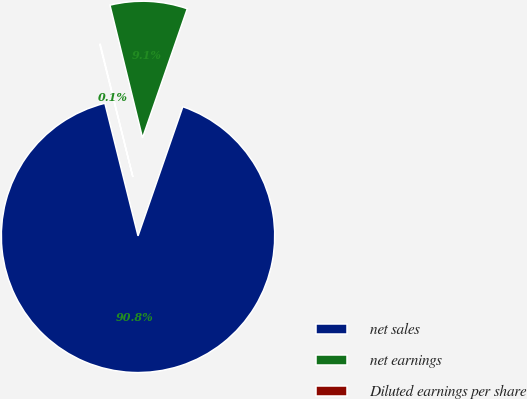<chart> <loc_0><loc_0><loc_500><loc_500><pie_chart><fcel>net sales<fcel>net earnings<fcel>Diluted earnings per share<nl><fcel>90.78%<fcel>9.14%<fcel>0.07%<nl></chart> 